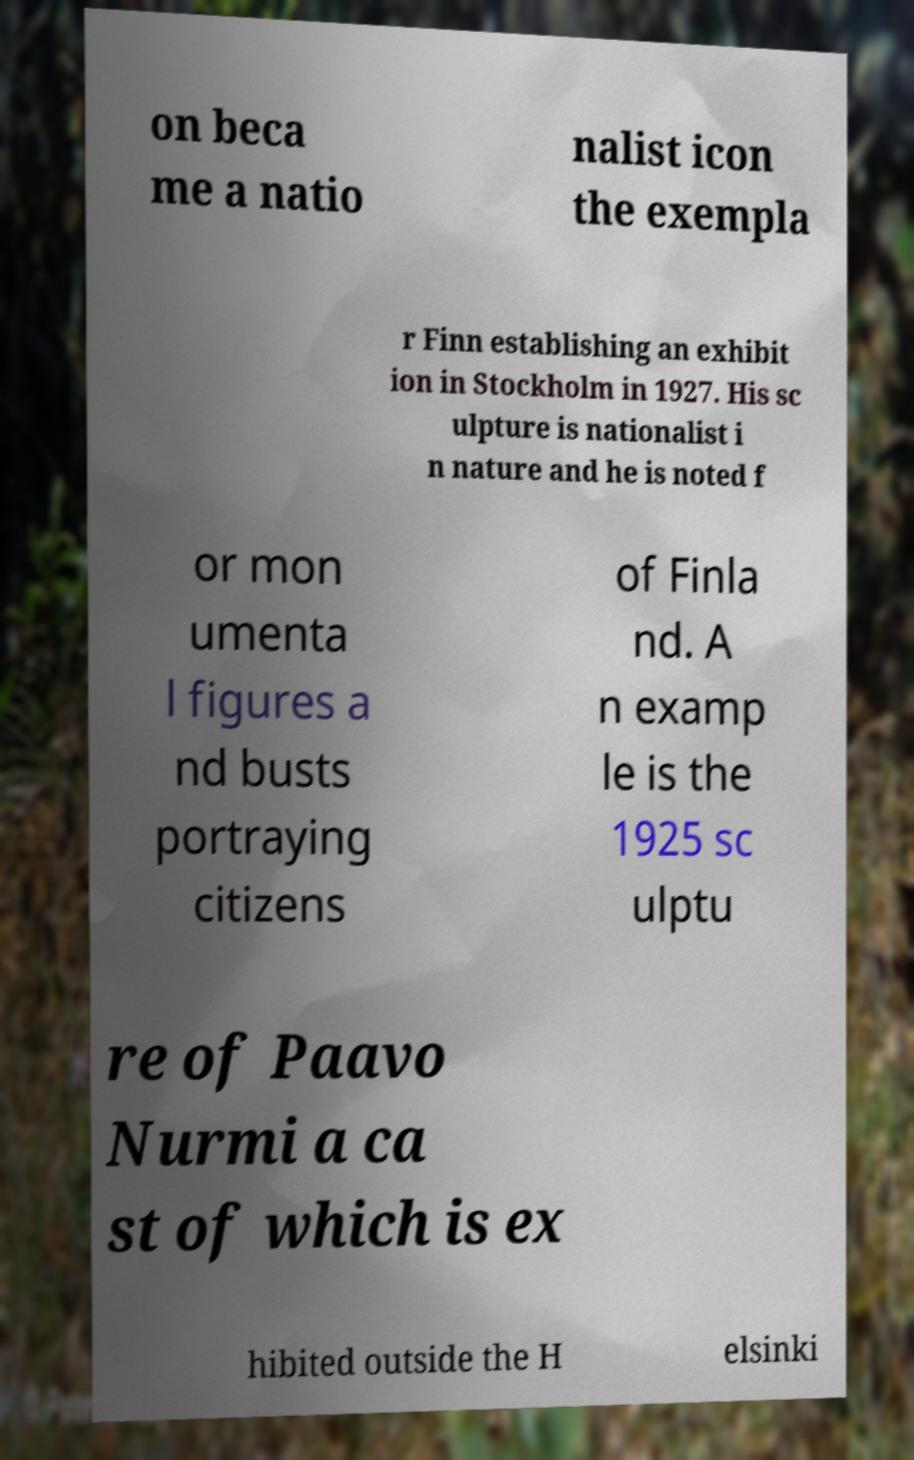Can you accurately transcribe the text from the provided image for me? on beca me a natio nalist icon the exempla r Finn establishing an exhibit ion in Stockholm in 1927. His sc ulpture is nationalist i n nature and he is noted f or mon umenta l figures a nd busts portraying citizens of Finla nd. A n examp le is the 1925 sc ulptu re of Paavo Nurmi a ca st of which is ex hibited outside the H elsinki 